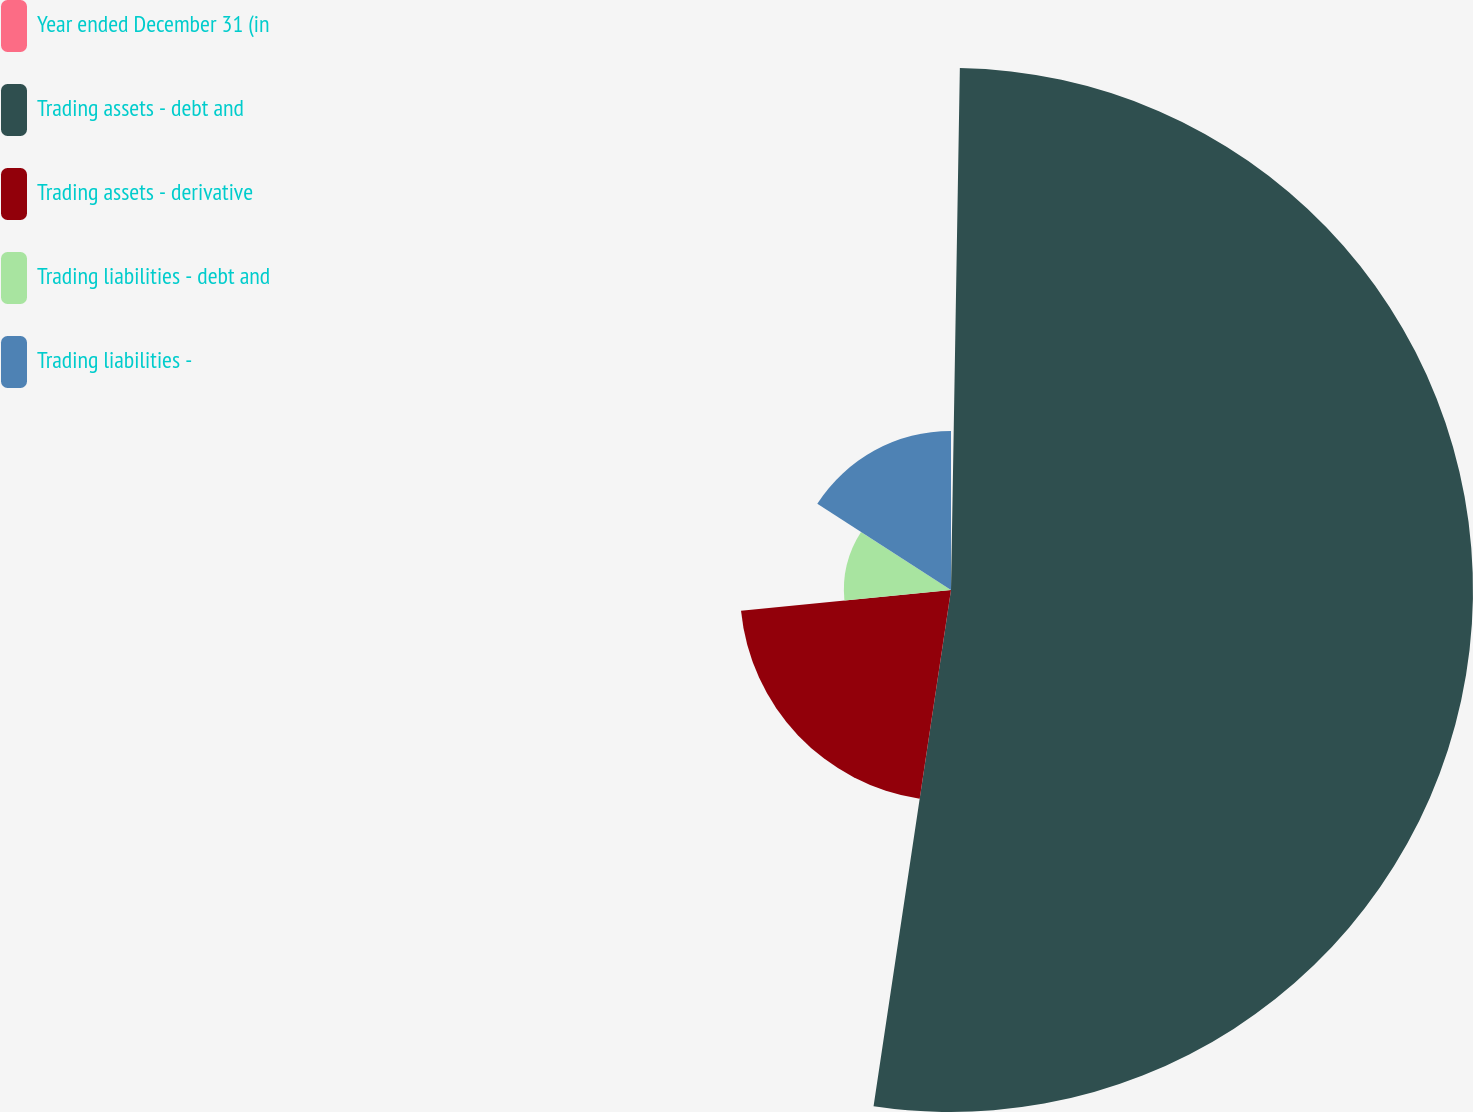<chart> <loc_0><loc_0><loc_500><loc_500><pie_chart><fcel>Year ended December 31 (in<fcel>Trading assets - debt and<fcel>Trading assets - derivative<fcel>Trading liabilities - debt and<fcel>Trading liabilities -<nl><fcel>0.27%<fcel>52.1%<fcel>21.06%<fcel>10.69%<fcel>15.88%<nl></chart> 